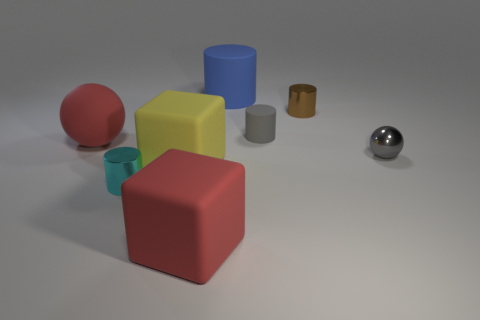Subtract 2 cylinders. How many cylinders are left? 2 Subtract all blue cylinders. How many cylinders are left? 3 Subtract all brown cylinders. How many cylinders are left? 3 Add 1 shiny cylinders. How many objects exist? 9 Subtract all blue cylinders. Subtract all cyan spheres. How many cylinders are left? 3 Subtract all cubes. How many objects are left? 6 Add 5 gray things. How many gray things are left? 7 Add 8 yellow shiny spheres. How many yellow shiny spheres exist? 8 Subtract 1 red spheres. How many objects are left? 7 Subtract all gray shiny things. Subtract all gray rubber cylinders. How many objects are left? 6 